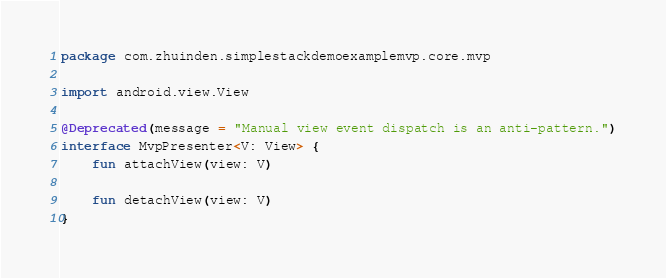Convert code to text. <code><loc_0><loc_0><loc_500><loc_500><_Kotlin_>package com.zhuinden.simplestackdemoexamplemvp.core.mvp

import android.view.View

@Deprecated(message = "Manual view event dispatch is an anti-pattern.")
interface MvpPresenter<V: View> {
    fun attachView(view: V)

    fun detachView(view: V)
}</code> 